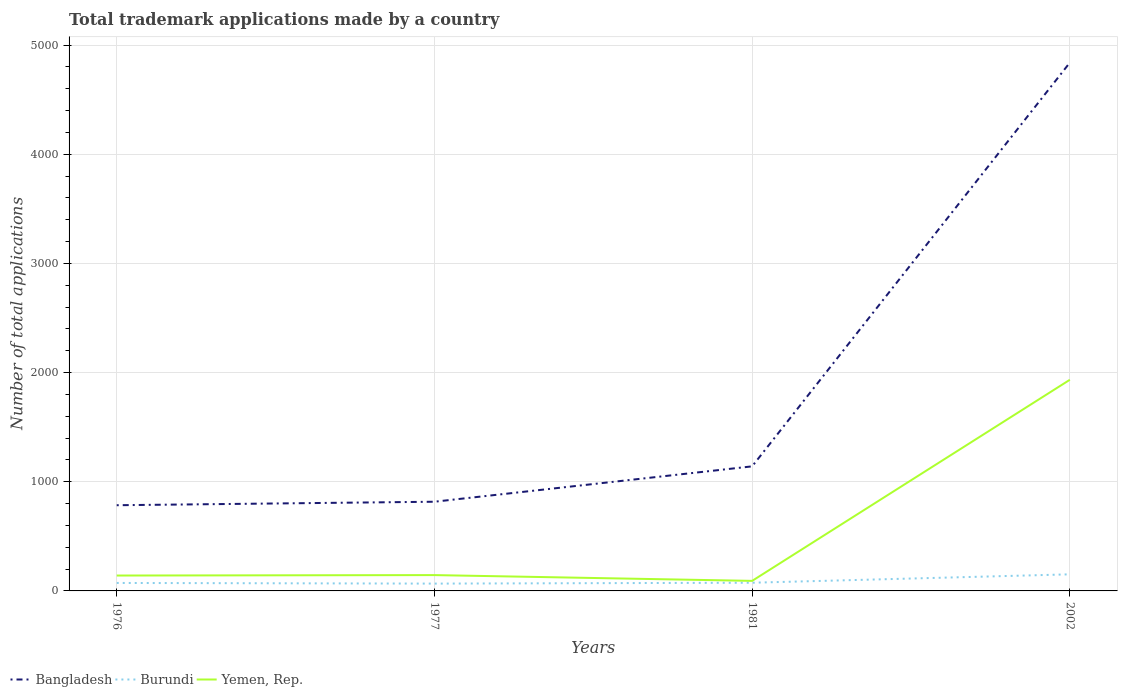Does the line corresponding to Yemen, Rep. intersect with the line corresponding to Bangladesh?
Ensure brevity in your answer.  No. Across all years, what is the maximum number of applications made by in Bangladesh?
Your answer should be very brief. 785. What is the total number of applications made by in Burundi in the graph?
Your answer should be very brief. -79. What is the difference between the highest and the second highest number of applications made by in Bangladesh?
Your answer should be compact. 4054. What is the difference between the highest and the lowest number of applications made by in Bangladesh?
Offer a very short reply. 1. Is the number of applications made by in Bangladesh strictly greater than the number of applications made by in Burundi over the years?
Provide a short and direct response. No. Are the values on the major ticks of Y-axis written in scientific E-notation?
Provide a short and direct response. No. Does the graph contain any zero values?
Offer a very short reply. No. How many legend labels are there?
Provide a short and direct response. 3. How are the legend labels stacked?
Ensure brevity in your answer.  Horizontal. What is the title of the graph?
Your answer should be compact. Total trademark applications made by a country. What is the label or title of the Y-axis?
Offer a very short reply. Number of total applications. What is the Number of total applications in Bangladesh in 1976?
Give a very brief answer. 785. What is the Number of total applications in Yemen, Rep. in 1976?
Your response must be concise. 141. What is the Number of total applications of Bangladesh in 1977?
Ensure brevity in your answer.  817. What is the Number of total applications in Burundi in 1977?
Provide a short and direct response. 67. What is the Number of total applications in Yemen, Rep. in 1977?
Your answer should be compact. 145. What is the Number of total applications in Bangladesh in 1981?
Provide a short and direct response. 1141. What is the Number of total applications of Burundi in 1981?
Offer a terse response. 75. What is the Number of total applications of Yemen, Rep. in 1981?
Keep it short and to the point. 92. What is the Number of total applications of Bangladesh in 2002?
Offer a terse response. 4839. What is the Number of total applications in Burundi in 2002?
Provide a succinct answer. 152. What is the Number of total applications of Yemen, Rep. in 2002?
Your answer should be very brief. 1934. Across all years, what is the maximum Number of total applications of Bangladesh?
Offer a terse response. 4839. Across all years, what is the maximum Number of total applications in Burundi?
Your answer should be very brief. 152. Across all years, what is the maximum Number of total applications in Yemen, Rep.?
Your answer should be very brief. 1934. Across all years, what is the minimum Number of total applications of Bangladesh?
Ensure brevity in your answer.  785. Across all years, what is the minimum Number of total applications in Yemen, Rep.?
Make the answer very short. 92. What is the total Number of total applications of Bangladesh in the graph?
Make the answer very short. 7582. What is the total Number of total applications in Burundi in the graph?
Provide a short and direct response. 367. What is the total Number of total applications in Yemen, Rep. in the graph?
Your answer should be very brief. 2312. What is the difference between the Number of total applications of Bangladesh in 1976 and that in 1977?
Provide a short and direct response. -32. What is the difference between the Number of total applications in Yemen, Rep. in 1976 and that in 1977?
Provide a short and direct response. -4. What is the difference between the Number of total applications in Bangladesh in 1976 and that in 1981?
Keep it short and to the point. -356. What is the difference between the Number of total applications of Burundi in 1976 and that in 1981?
Provide a short and direct response. -2. What is the difference between the Number of total applications of Bangladesh in 1976 and that in 2002?
Give a very brief answer. -4054. What is the difference between the Number of total applications in Burundi in 1976 and that in 2002?
Offer a very short reply. -79. What is the difference between the Number of total applications in Yemen, Rep. in 1976 and that in 2002?
Your response must be concise. -1793. What is the difference between the Number of total applications in Bangladesh in 1977 and that in 1981?
Your answer should be compact. -324. What is the difference between the Number of total applications in Burundi in 1977 and that in 1981?
Ensure brevity in your answer.  -8. What is the difference between the Number of total applications in Bangladesh in 1977 and that in 2002?
Your response must be concise. -4022. What is the difference between the Number of total applications of Burundi in 1977 and that in 2002?
Provide a succinct answer. -85. What is the difference between the Number of total applications of Yemen, Rep. in 1977 and that in 2002?
Provide a short and direct response. -1789. What is the difference between the Number of total applications in Bangladesh in 1981 and that in 2002?
Make the answer very short. -3698. What is the difference between the Number of total applications in Burundi in 1981 and that in 2002?
Make the answer very short. -77. What is the difference between the Number of total applications of Yemen, Rep. in 1981 and that in 2002?
Your response must be concise. -1842. What is the difference between the Number of total applications of Bangladesh in 1976 and the Number of total applications of Burundi in 1977?
Make the answer very short. 718. What is the difference between the Number of total applications in Bangladesh in 1976 and the Number of total applications in Yemen, Rep. in 1977?
Provide a succinct answer. 640. What is the difference between the Number of total applications in Burundi in 1976 and the Number of total applications in Yemen, Rep. in 1977?
Your answer should be very brief. -72. What is the difference between the Number of total applications in Bangladesh in 1976 and the Number of total applications in Burundi in 1981?
Provide a short and direct response. 710. What is the difference between the Number of total applications of Bangladesh in 1976 and the Number of total applications of Yemen, Rep. in 1981?
Offer a very short reply. 693. What is the difference between the Number of total applications of Burundi in 1976 and the Number of total applications of Yemen, Rep. in 1981?
Offer a very short reply. -19. What is the difference between the Number of total applications in Bangladesh in 1976 and the Number of total applications in Burundi in 2002?
Give a very brief answer. 633. What is the difference between the Number of total applications of Bangladesh in 1976 and the Number of total applications of Yemen, Rep. in 2002?
Offer a terse response. -1149. What is the difference between the Number of total applications in Burundi in 1976 and the Number of total applications in Yemen, Rep. in 2002?
Offer a terse response. -1861. What is the difference between the Number of total applications of Bangladesh in 1977 and the Number of total applications of Burundi in 1981?
Ensure brevity in your answer.  742. What is the difference between the Number of total applications of Bangladesh in 1977 and the Number of total applications of Yemen, Rep. in 1981?
Offer a terse response. 725. What is the difference between the Number of total applications of Burundi in 1977 and the Number of total applications of Yemen, Rep. in 1981?
Offer a very short reply. -25. What is the difference between the Number of total applications of Bangladesh in 1977 and the Number of total applications of Burundi in 2002?
Offer a very short reply. 665. What is the difference between the Number of total applications in Bangladesh in 1977 and the Number of total applications in Yemen, Rep. in 2002?
Ensure brevity in your answer.  -1117. What is the difference between the Number of total applications in Burundi in 1977 and the Number of total applications in Yemen, Rep. in 2002?
Your answer should be compact. -1867. What is the difference between the Number of total applications in Bangladesh in 1981 and the Number of total applications in Burundi in 2002?
Your response must be concise. 989. What is the difference between the Number of total applications in Bangladesh in 1981 and the Number of total applications in Yemen, Rep. in 2002?
Provide a succinct answer. -793. What is the difference between the Number of total applications of Burundi in 1981 and the Number of total applications of Yemen, Rep. in 2002?
Provide a short and direct response. -1859. What is the average Number of total applications of Bangladesh per year?
Your response must be concise. 1895.5. What is the average Number of total applications in Burundi per year?
Offer a very short reply. 91.75. What is the average Number of total applications of Yemen, Rep. per year?
Your answer should be very brief. 578. In the year 1976, what is the difference between the Number of total applications in Bangladesh and Number of total applications in Burundi?
Your response must be concise. 712. In the year 1976, what is the difference between the Number of total applications in Bangladesh and Number of total applications in Yemen, Rep.?
Ensure brevity in your answer.  644. In the year 1976, what is the difference between the Number of total applications of Burundi and Number of total applications of Yemen, Rep.?
Your answer should be compact. -68. In the year 1977, what is the difference between the Number of total applications in Bangladesh and Number of total applications in Burundi?
Offer a very short reply. 750. In the year 1977, what is the difference between the Number of total applications in Bangladesh and Number of total applications in Yemen, Rep.?
Your answer should be compact. 672. In the year 1977, what is the difference between the Number of total applications in Burundi and Number of total applications in Yemen, Rep.?
Give a very brief answer. -78. In the year 1981, what is the difference between the Number of total applications in Bangladesh and Number of total applications in Burundi?
Make the answer very short. 1066. In the year 1981, what is the difference between the Number of total applications in Bangladesh and Number of total applications in Yemen, Rep.?
Provide a short and direct response. 1049. In the year 1981, what is the difference between the Number of total applications of Burundi and Number of total applications of Yemen, Rep.?
Make the answer very short. -17. In the year 2002, what is the difference between the Number of total applications of Bangladesh and Number of total applications of Burundi?
Provide a succinct answer. 4687. In the year 2002, what is the difference between the Number of total applications in Bangladesh and Number of total applications in Yemen, Rep.?
Your response must be concise. 2905. In the year 2002, what is the difference between the Number of total applications in Burundi and Number of total applications in Yemen, Rep.?
Make the answer very short. -1782. What is the ratio of the Number of total applications in Bangladesh in 1976 to that in 1977?
Offer a very short reply. 0.96. What is the ratio of the Number of total applications of Burundi in 1976 to that in 1977?
Make the answer very short. 1.09. What is the ratio of the Number of total applications of Yemen, Rep. in 1976 to that in 1977?
Keep it short and to the point. 0.97. What is the ratio of the Number of total applications of Bangladesh in 1976 to that in 1981?
Ensure brevity in your answer.  0.69. What is the ratio of the Number of total applications of Burundi in 1976 to that in 1981?
Your answer should be compact. 0.97. What is the ratio of the Number of total applications in Yemen, Rep. in 1976 to that in 1981?
Your answer should be compact. 1.53. What is the ratio of the Number of total applications in Bangladesh in 1976 to that in 2002?
Your response must be concise. 0.16. What is the ratio of the Number of total applications in Burundi in 1976 to that in 2002?
Ensure brevity in your answer.  0.48. What is the ratio of the Number of total applications in Yemen, Rep. in 1976 to that in 2002?
Provide a succinct answer. 0.07. What is the ratio of the Number of total applications in Bangladesh in 1977 to that in 1981?
Ensure brevity in your answer.  0.72. What is the ratio of the Number of total applications of Burundi in 1977 to that in 1981?
Make the answer very short. 0.89. What is the ratio of the Number of total applications of Yemen, Rep. in 1977 to that in 1981?
Ensure brevity in your answer.  1.58. What is the ratio of the Number of total applications in Bangladesh in 1977 to that in 2002?
Provide a succinct answer. 0.17. What is the ratio of the Number of total applications of Burundi in 1977 to that in 2002?
Keep it short and to the point. 0.44. What is the ratio of the Number of total applications of Yemen, Rep. in 1977 to that in 2002?
Ensure brevity in your answer.  0.07. What is the ratio of the Number of total applications in Bangladesh in 1981 to that in 2002?
Provide a succinct answer. 0.24. What is the ratio of the Number of total applications of Burundi in 1981 to that in 2002?
Provide a short and direct response. 0.49. What is the ratio of the Number of total applications in Yemen, Rep. in 1981 to that in 2002?
Keep it short and to the point. 0.05. What is the difference between the highest and the second highest Number of total applications of Bangladesh?
Your answer should be very brief. 3698. What is the difference between the highest and the second highest Number of total applications of Burundi?
Your answer should be very brief. 77. What is the difference between the highest and the second highest Number of total applications in Yemen, Rep.?
Your response must be concise. 1789. What is the difference between the highest and the lowest Number of total applications of Bangladesh?
Your response must be concise. 4054. What is the difference between the highest and the lowest Number of total applications in Burundi?
Your answer should be very brief. 85. What is the difference between the highest and the lowest Number of total applications in Yemen, Rep.?
Keep it short and to the point. 1842. 